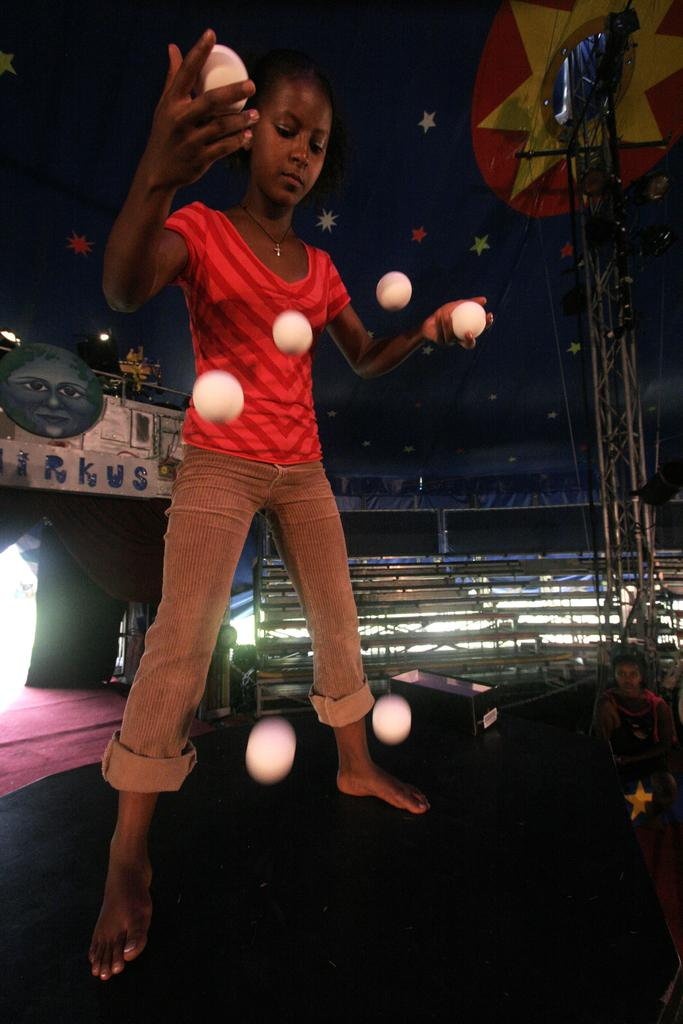Who is the main subject in the image? There is a girl in the image. What is the girl doing in the image? The girl is standing and juggling with balls. What can be seen in the background of the image? There is a lighting truss, benches, a tent, boards, and a person in the background of the image. Can you describe the setting of the image? The image appears to be taken at an outdoor event or gathering, given the presence of a tent and benches. What is the topic of the discussion taking place in the image? There is no discussion taking place in the image; it shows a girl juggling with balls and various background elements. 